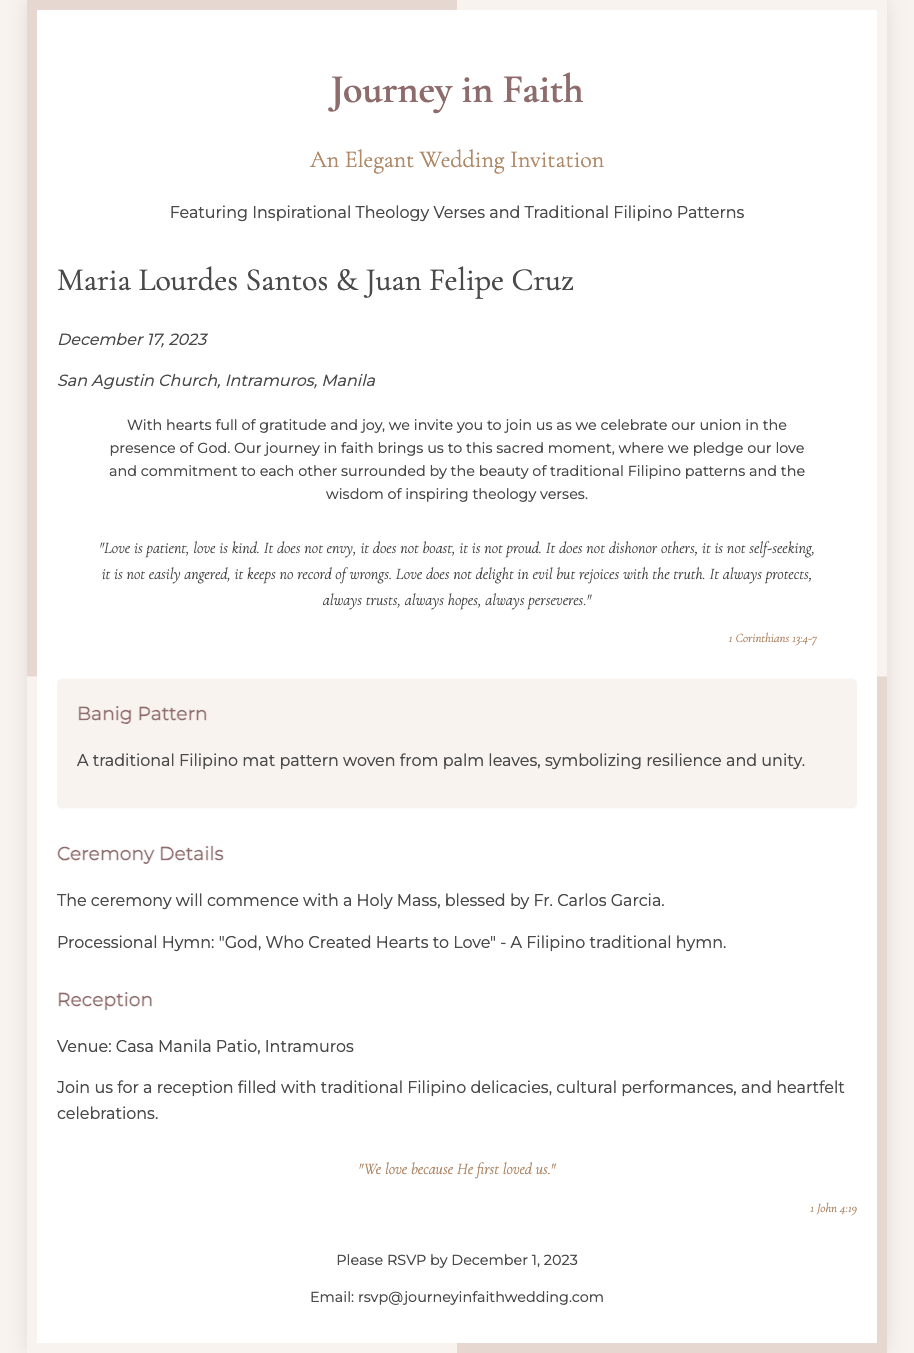What are the names of the couple? The couple's names are prominently displayed in the document and are Maria Lourdes Santos & Juan Felipe Cruz.
Answer: Maria Lourdes Santos & Juan Felipe Cruz When is the wedding date? The wedding date is mentioned in the date-venue section of the document.
Answer: December 17, 2023 Where will the ceremony take place? The location of the ceremony is provided in the date-venue section of the document.
Answer: San Agustin Church, Intramuros, Manila What is the theme of the wedding invitation? The title of the invitation indicates the main theme, which reflects their journey of faith.
Answer: Journey in Faith What is the introductory message about? The introduction conveys the couple's emotions and the significance of their union, highlighting gratitude and faith.
Answer: Gratitude and joy Which theological verse is featured in the invitation? The verse is an important part of the invitation, and it is from the book of Corinthians.
Answer: 1 Corinthians 13:4-7 What is the closing quote? The closing quote is an important theological statement found at the end of the invitation.
Answer: "We love because He first loved us." What is the reception venue? The venue for the reception is provided under the reception details in the document.
Answer: Casa Manila Patio, Intramuros What is the RSVP deadline? The RSVP deadline is stated clearly within the invitation for guests to respond.
Answer: December 1, 2023 